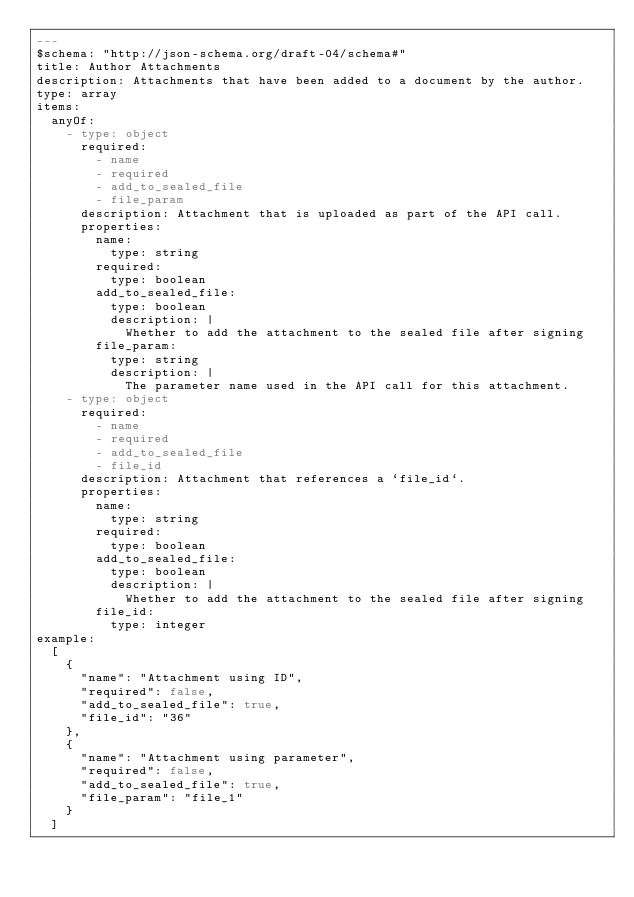<code> <loc_0><loc_0><loc_500><loc_500><_YAML_>---
$schema: "http://json-schema.org/draft-04/schema#"
title: Author Attachments
description: Attachments that have been added to a document by the author.
type: array
items:
  anyOf:
    - type: object
      required:
        - name
        - required
        - add_to_sealed_file
        - file_param
      description: Attachment that is uploaded as part of the API call.
      properties:
        name:
          type: string
        required:
          type: boolean
        add_to_sealed_file:
          type: boolean
          description: |
            Whether to add the attachment to the sealed file after signing
        file_param:
          type: string
          description: |
            The parameter name used in the API call for this attachment.
    - type: object
      required:
        - name
        - required
        - add_to_sealed_file
        - file_id
      description: Attachment that references a `file_id`.
      properties:
        name:
          type: string
        required:
          type: boolean
        add_to_sealed_file:
          type: boolean
          description: |
            Whether to add the attachment to the sealed file after signing
        file_id:
          type: integer
example:
  [
    {
      "name": "Attachment using ID",
      "required": false,
      "add_to_sealed_file": true,
      "file_id": "36"
    },
    {
      "name": "Attachment using parameter",
      "required": false,
      "add_to_sealed_file": true,
      "file_param": "file_1"
    }
  ]
</code> 